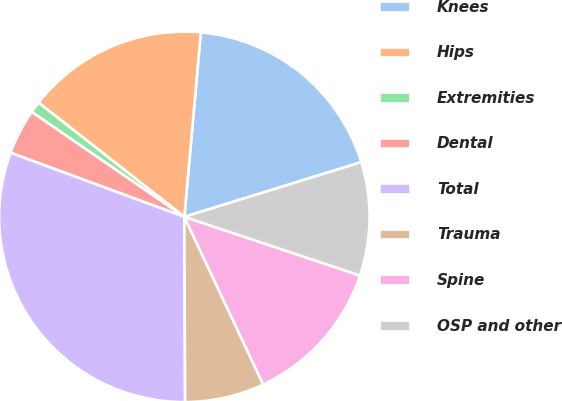Convert chart. <chart><loc_0><loc_0><loc_500><loc_500><pie_chart><fcel>Knees<fcel>Hips<fcel>Extremities<fcel>Dental<fcel>Total<fcel>Trauma<fcel>Spine<fcel>OSP and other<nl><fcel>18.81%<fcel>15.84%<fcel>0.99%<fcel>3.96%<fcel>30.69%<fcel>6.93%<fcel>12.87%<fcel>9.9%<nl></chart> 